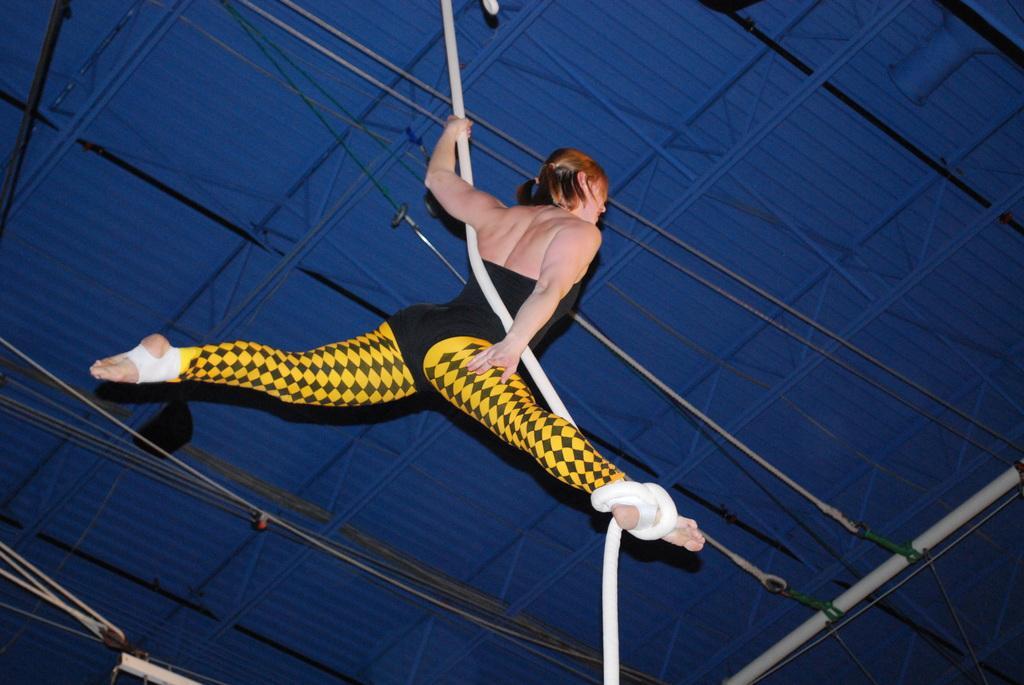How would you summarize this image in a sentence or two? In this image, we can see a person hanging on rope. In the background, we can see support beams and ropes. 